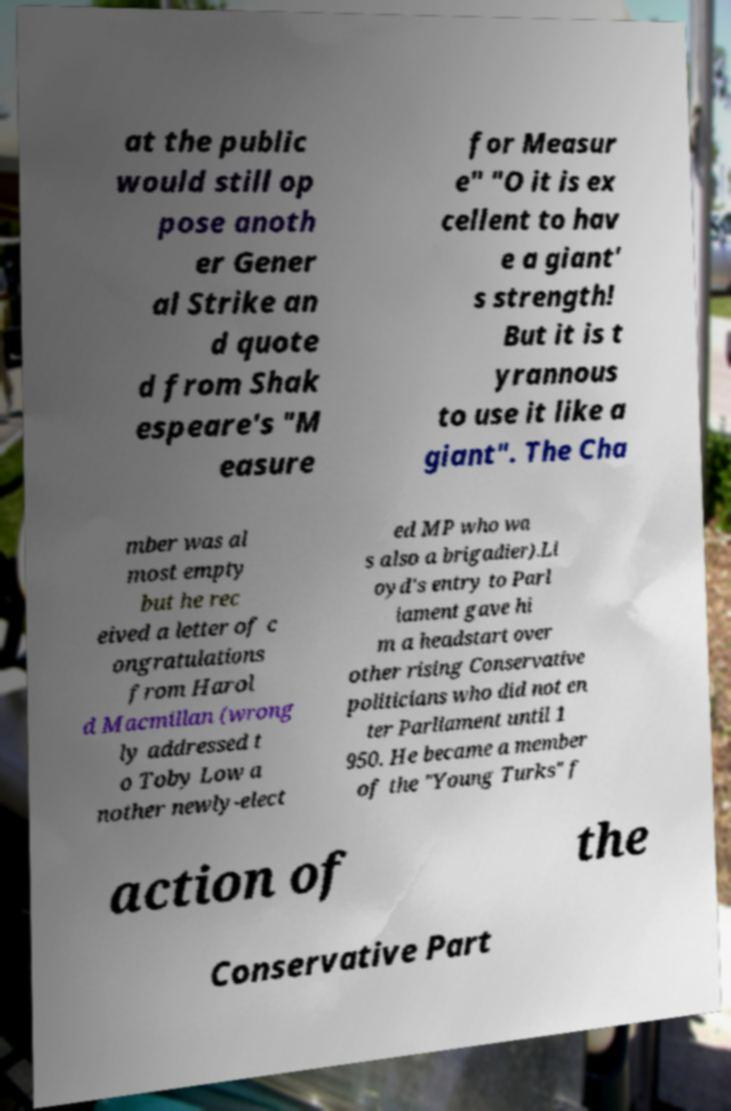What messages or text are displayed in this image? I need them in a readable, typed format. at the public would still op pose anoth er Gener al Strike an d quote d from Shak espeare's "M easure for Measur e" "O it is ex cellent to hav e a giant' s strength! But it is t yrannous to use it like a giant". The Cha mber was al most empty but he rec eived a letter of c ongratulations from Harol d Macmillan (wrong ly addressed t o Toby Low a nother newly-elect ed MP who wa s also a brigadier).Ll oyd's entry to Parl iament gave hi m a headstart over other rising Conservative politicians who did not en ter Parliament until 1 950. He became a member of the "Young Turks" f action of the Conservative Part 